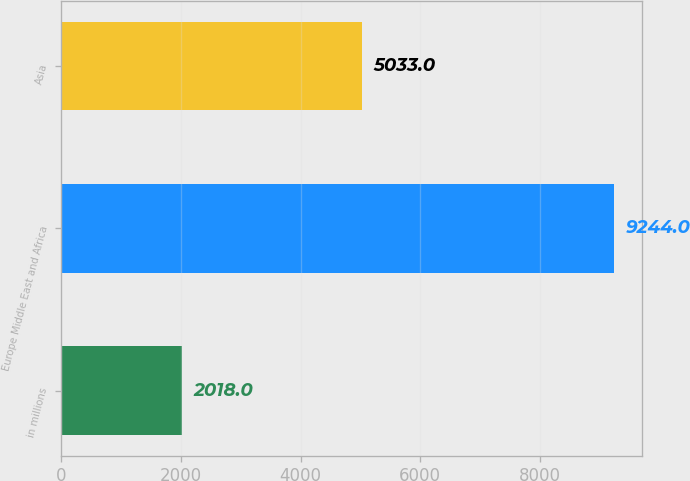<chart> <loc_0><loc_0><loc_500><loc_500><bar_chart><fcel>in millions<fcel>Europe Middle East and Africa<fcel>Asia<nl><fcel>2018<fcel>9244<fcel>5033<nl></chart> 